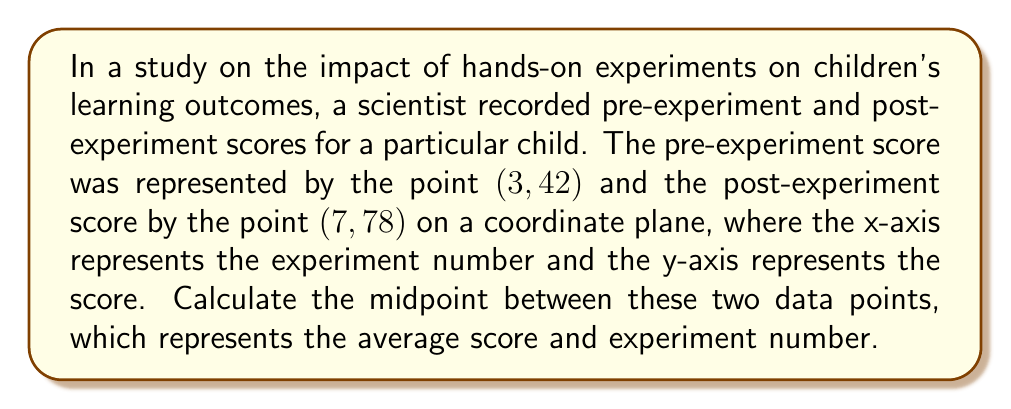Show me your answer to this math problem. To find the midpoint between two points, we use the midpoint formula:

$$ \text{Midpoint} = \left(\frac{x_1 + x_2}{2}, \frac{y_1 + y_2}{2}\right) $$

Where $(x_1, y_1)$ is the first point and $(x_2, y_2)$ is the second point.

In this case:
$(x_1, y_1) = (3, 42)$ (pre-experiment score)
$(x_2, y_2) = (7, 78)$ (post-experiment score)

Let's calculate each coordinate of the midpoint separately:

1. x-coordinate of the midpoint:
   $$ \frac{x_1 + x_2}{2} = \frac{3 + 7}{2} = \frac{10}{2} = 5 $$

2. y-coordinate of the midpoint:
   $$ \frac{y_1 + y_2}{2} = \frac{42 + 78}{2} = \frac{120}{2} = 60 $$

Therefore, the midpoint is $(5, 60)$.
Answer: The midpoint between the pre-experiment score $(3, 42)$ and the post-experiment score $(7, 78)$ is $(5, 60)$. 